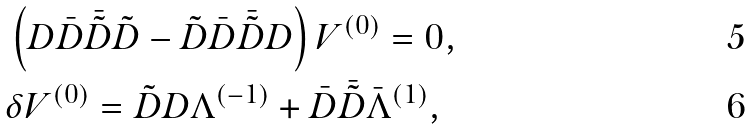<formula> <loc_0><loc_0><loc_500><loc_500>& \left ( D \bar { D } \bar { \tilde { D } } \tilde { D } - \tilde { D } \bar { D } \bar { \tilde { D } } D \right ) V ^ { ( 0 ) } = 0 , \\ & \delta V ^ { ( 0 ) } = \tilde { D } D \Lambda ^ { ( - 1 ) } + \bar { D } \bar { \tilde { D } } \bar { \Lambda } ^ { ( 1 ) } ,</formula> 